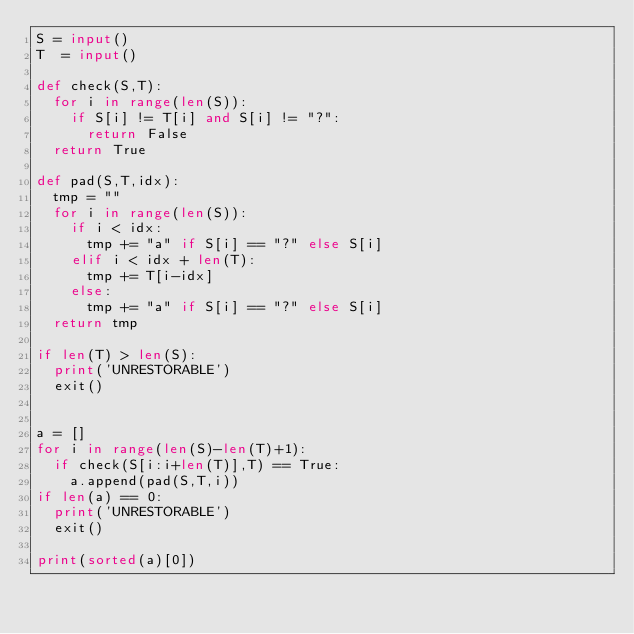<code> <loc_0><loc_0><loc_500><loc_500><_Python_>S = input()
T  = input()

def check(S,T):
	for i in range(len(S)):
		if S[i] != T[i] and S[i] != "?":
			return False
	return True

def pad(S,T,idx):
	tmp = ""
	for i in range(len(S)):
		if i < idx:
			tmp += "a" if S[i] == "?" else S[i]
		elif i < idx + len(T):
			tmp += T[i-idx]
		else:
			tmp += "a" if S[i] == "?" else S[i]
	return tmp

if len(T) > len(S):
	print('UNRESTORABLE')
	exit()


a = []
for i in range(len(S)-len(T)+1):
	if check(S[i:i+len(T)],T) == True:
		a.append(pad(S,T,i))
if len(a) == 0:
	print('UNRESTORABLE')
	exit()

print(sorted(a)[0])

</code> 